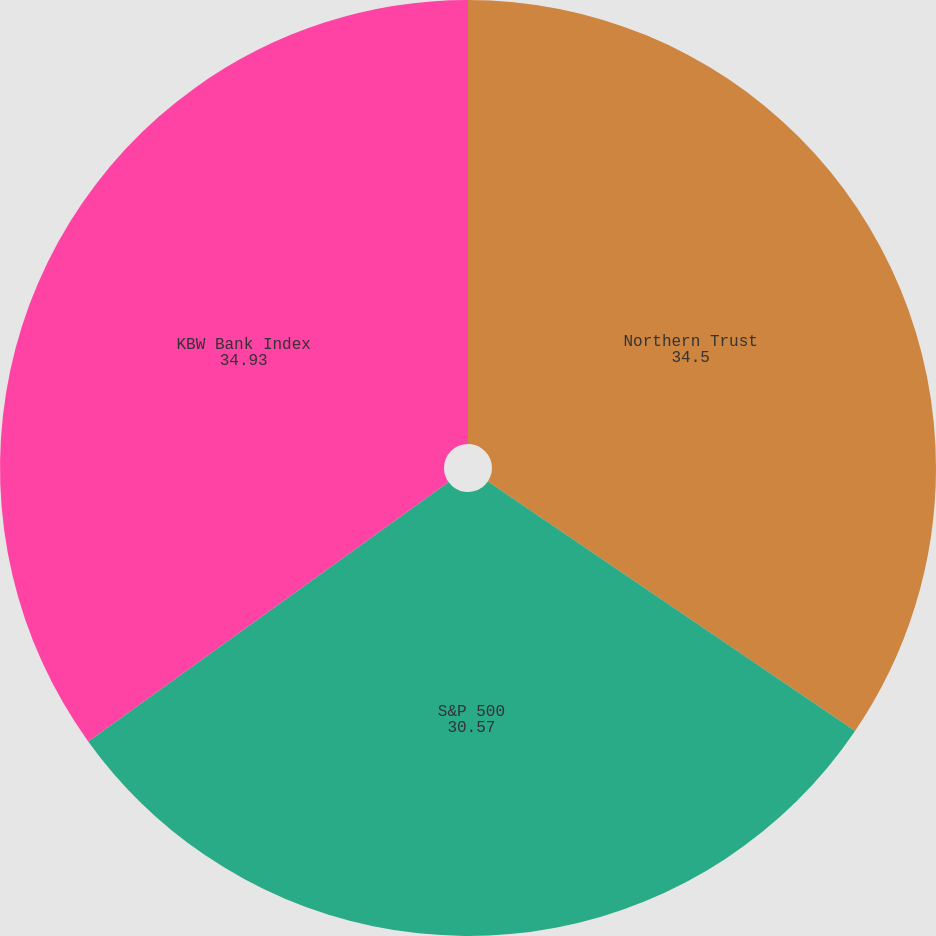Convert chart. <chart><loc_0><loc_0><loc_500><loc_500><pie_chart><fcel>Northern Trust<fcel>S&P 500<fcel>KBW Bank Index<nl><fcel>34.5%<fcel>30.57%<fcel>34.93%<nl></chart> 